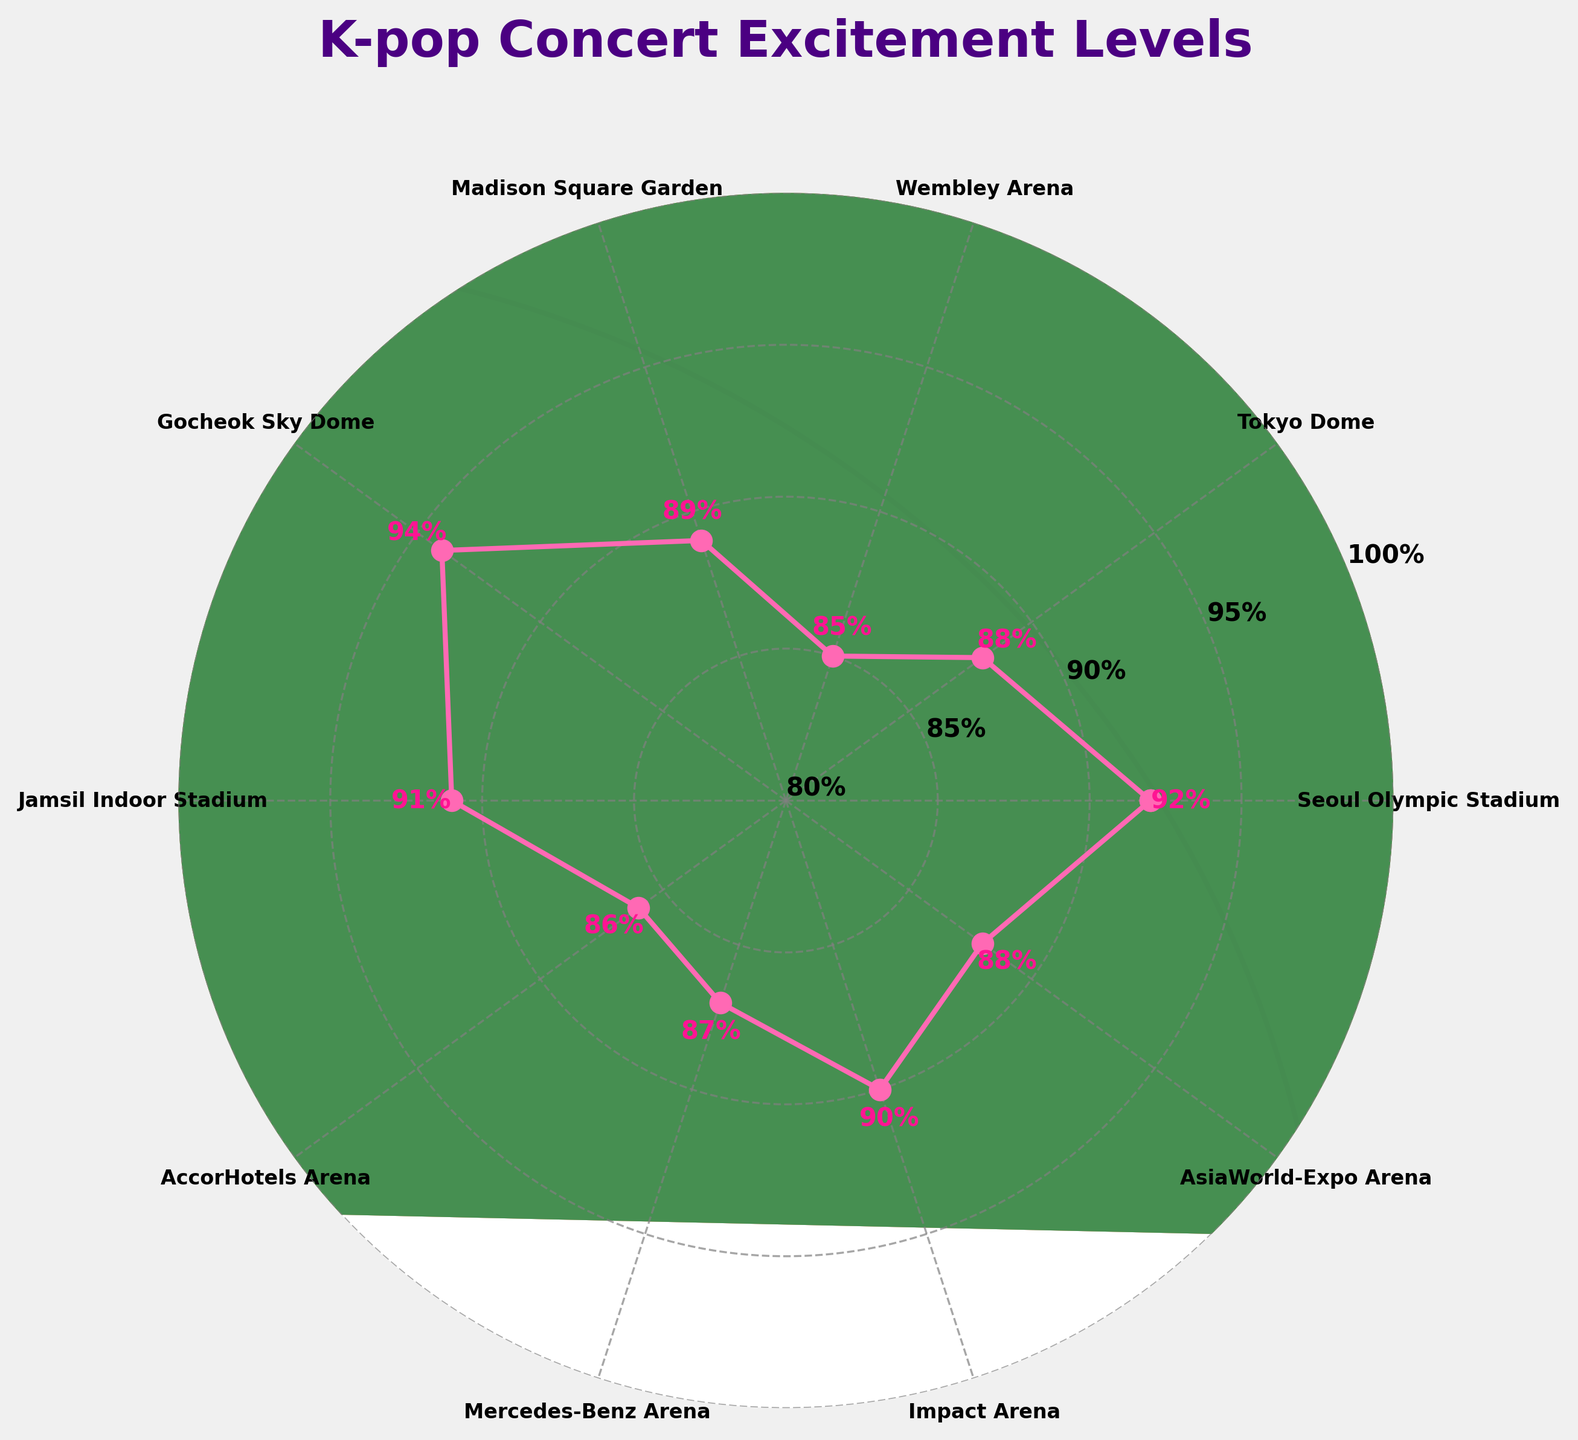What is the title of the chart? The title is usually displayed prominently on the chart. Here, the title reads "K-pop Concert Excitement Levels".
Answer: K-pop Concert Excitement Levels How many concert venues are shown in the chart? The chart plots points around a circle for different concert venues, each venue representing a data point. Counting these points gives us 10 venues.
Answer: 10 Which concert venue has the highest audience excitement level? The highest point on the radial chart represents the highest excitement level. The label near this point indicates "Gocheok Sky Dome" with an excitement level of 94%.
Answer: Gocheok Sky Dome What is the excitement level at Madison Square Garden? The label associated with Madison Square Garden in the chart displays its excitement level as a percentage, which is 89%.
Answer: 89% Compare the excitement levels of Seoul Olympic Stadium and Jamsil Indoor Stadium. Which one is higher? The points and labels for Seoul Olympic Stadium and Jamsil Indoor Stadium can be directly compared. Seoul Olympic Stadium has an excitement level of 92%, while Jamsil Indoor Stadium has 91%. Hence, Seoul Olympic Stadium is higher.
Answer: Seoul Olympic Stadium What is the average audience excitement level across all venues? To find the average, sum all the excitement levels and divide by the number of venues. The sum is 92+88+85+89+94+91+86+87+90+88=890. Dividing by 10, the average is 890/10 = 89%.
Answer: 89% Is there any concert venue with an excitement level below 85%? The excitement levels range from 85% to 94% as shown by the labels on the chart. None of the venues have excitement levels below 85%.
Answer: No Which venue has an excitement level closest to the median of all venues' excitement levels? Sorting the excitement levels we get: 85, 86, 87, 88, 88, 89, 90, 91, 92, 94. The median is the average of the 5th and 6th values: (88+89)/2 = 88.5%. The closest level to this median is 88%, with both Tokyo Dome and AsiaWorld-Expo Arena having this level.
Answer: Tokyo Dome and AsiaWorld-Expo Arena Between Mercedes-Benz Arena and AccorHotels Arena, which venue has a higher excitement level? The chart shows the excitement levels with labels. Mercedes-Benz Arena has 87%, while AccorHotels Arena has 86%. Therefore, Mercedes-Benz Arena is higher.
Answer: Mercedes-Benz Arena 